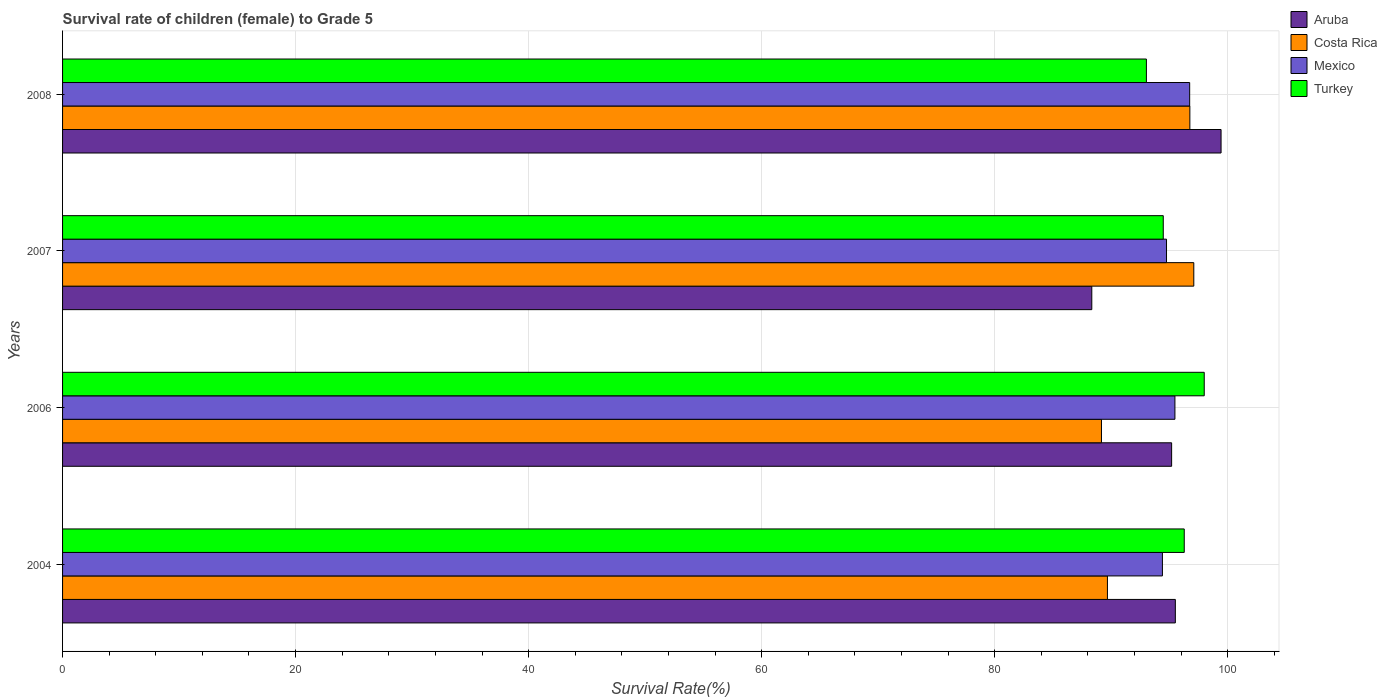How many different coloured bars are there?
Ensure brevity in your answer.  4. Are the number of bars per tick equal to the number of legend labels?
Provide a succinct answer. Yes. How many bars are there on the 4th tick from the top?
Make the answer very short. 4. How many bars are there on the 1st tick from the bottom?
Ensure brevity in your answer.  4. What is the label of the 4th group of bars from the top?
Make the answer very short. 2004. What is the survival rate of female children to grade 5 in Aruba in 2007?
Give a very brief answer. 88.34. Across all years, what is the maximum survival rate of female children to grade 5 in Costa Rica?
Make the answer very short. 97.09. Across all years, what is the minimum survival rate of female children to grade 5 in Costa Rica?
Offer a terse response. 89.17. What is the total survival rate of female children to grade 5 in Aruba in the graph?
Give a very brief answer. 378.48. What is the difference between the survival rate of female children to grade 5 in Turkey in 2007 and that in 2008?
Your answer should be very brief. 1.45. What is the difference between the survival rate of female children to grade 5 in Costa Rica in 2004 and the survival rate of female children to grade 5 in Mexico in 2007?
Keep it short and to the point. -5.07. What is the average survival rate of female children to grade 5 in Turkey per year?
Make the answer very short. 95.44. In the year 2008, what is the difference between the survival rate of female children to grade 5 in Costa Rica and survival rate of female children to grade 5 in Mexico?
Make the answer very short. 0.02. What is the ratio of the survival rate of female children to grade 5 in Turkey in 2006 to that in 2008?
Offer a very short reply. 1.05. Is the difference between the survival rate of female children to grade 5 in Costa Rica in 2004 and 2007 greater than the difference between the survival rate of female children to grade 5 in Mexico in 2004 and 2007?
Your answer should be very brief. No. What is the difference between the highest and the second highest survival rate of female children to grade 5 in Turkey?
Keep it short and to the point. 1.72. What is the difference between the highest and the lowest survival rate of female children to grade 5 in Aruba?
Give a very brief answer. 11.1. In how many years, is the survival rate of female children to grade 5 in Mexico greater than the average survival rate of female children to grade 5 in Mexico taken over all years?
Offer a terse response. 2. Is the sum of the survival rate of female children to grade 5 in Aruba in 2004 and 2008 greater than the maximum survival rate of female children to grade 5 in Turkey across all years?
Make the answer very short. Yes. What does the 1st bar from the top in 2007 represents?
Your answer should be compact. Turkey. What does the 4th bar from the bottom in 2004 represents?
Offer a very short reply. Turkey. Is it the case that in every year, the sum of the survival rate of female children to grade 5 in Aruba and survival rate of female children to grade 5 in Costa Rica is greater than the survival rate of female children to grade 5 in Turkey?
Offer a terse response. Yes. What is the difference between two consecutive major ticks on the X-axis?
Make the answer very short. 20. Are the values on the major ticks of X-axis written in scientific E-notation?
Ensure brevity in your answer.  No. Does the graph contain grids?
Make the answer very short. Yes. How are the legend labels stacked?
Your answer should be very brief. Vertical. What is the title of the graph?
Make the answer very short. Survival rate of children (female) to Grade 5. What is the label or title of the X-axis?
Ensure brevity in your answer.  Survival Rate(%). What is the label or title of the Y-axis?
Your response must be concise. Years. What is the Survival Rate(%) in Aruba in 2004?
Keep it short and to the point. 95.51. What is the Survival Rate(%) in Costa Rica in 2004?
Provide a succinct answer. 89.68. What is the Survival Rate(%) of Mexico in 2004?
Provide a succinct answer. 94.4. What is the Survival Rate(%) of Turkey in 2004?
Offer a terse response. 96.27. What is the Survival Rate(%) in Aruba in 2006?
Give a very brief answer. 95.19. What is the Survival Rate(%) in Costa Rica in 2006?
Your response must be concise. 89.17. What is the Survival Rate(%) of Mexico in 2006?
Provide a short and direct response. 95.47. What is the Survival Rate(%) in Turkey in 2006?
Offer a very short reply. 97.99. What is the Survival Rate(%) of Aruba in 2007?
Make the answer very short. 88.34. What is the Survival Rate(%) in Costa Rica in 2007?
Make the answer very short. 97.09. What is the Survival Rate(%) of Mexico in 2007?
Your response must be concise. 94.75. What is the Survival Rate(%) in Turkey in 2007?
Offer a terse response. 94.47. What is the Survival Rate(%) in Aruba in 2008?
Your response must be concise. 99.44. What is the Survival Rate(%) of Costa Rica in 2008?
Make the answer very short. 96.76. What is the Survival Rate(%) in Mexico in 2008?
Ensure brevity in your answer.  96.74. What is the Survival Rate(%) of Turkey in 2008?
Your answer should be very brief. 93.03. Across all years, what is the maximum Survival Rate(%) of Aruba?
Your answer should be very brief. 99.44. Across all years, what is the maximum Survival Rate(%) of Costa Rica?
Give a very brief answer. 97.09. Across all years, what is the maximum Survival Rate(%) in Mexico?
Make the answer very short. 96.74. Across all years, what is the maximum Survival Rate(%) of Turkey?
Your answer should be very brief. 97.99. Across all years, what is the minimum Survival Rate(%) in Aruba?
Give a very brief answer. 88.34. Across all years, what is the minimum Survival Rate(%) in Costa Rica?
Provide a succinct answer. 89.17. Across all years, what is the minimum Survival Rate(%) in Mexico?
Keep it short and to the point. 94.4. Across all years, what is the minimum Survival Rate(%) in Turkey?
Your answer should be compact. 93.03. What is the total Survival Rate(%) in Aruba in the graph?
Keep it short and to the point. 378.48. What is the total Survival Rate(%) of Costa Rica in the graph?
Your answer should be very brief. 372.7. What is the total Survival Rate(%) of Mexico in the graph?
Give a very brief answer. 381.37. What is the total Survival Rate(%) in Turkey in the graph?
Provide a succinct answer. 381.77. What is the difference between the Survival Rate(%) of Aruba in 2004 and that in 2006?
Your response must be concise. 0.32. What is the difference between the Survival Rate(%) in Costa Rica in 2004 and that in 2006?
Your response must be concise. 0.51. What is the difference between the Survival Rate(%) of Mexico in 2004 and that in 2006?
Provide a short and direct response. -1.07. What is the difference between the Survival Rate(%) in Turkey in 2004 and that in 2006?
Your answer should be compact. -1.72. What is the difference between the Survival Rate(%) of Aruba in 2004 and that in 2007?
Provide a short and direct response. 7.17. What is the difference between the Survival Rate(%) in Costa Rica in 2004 and that in 2007?
Ensure brevity in your answer.  -7.41. What is the difference between the Survival Rate(%) in Mexico in 2004 and that in 2007?
Your answer should be compact. -0.35. What is the difference between the Survival Rate(%) in Turkey in 2004 and that in 2007?
Offer a very short reply. 1.8. What is the difference between the Survival Rate(%) in Aruba in 2004 and that in 2008?
Offer a very short reply. -3.92. What is the difference between the Survival Rate(%) of Costa Rica in 2004 and that in 2008?
Offer a terse response. -7.08. What is the difference between the Survival Rate(%) of Mexico in 2004 and that in 2008?
Your answer should be very brief. -2.34. What is the difference between the Survival Rate(%) in Turkey in 2004 and that in 2008?
Give a very brief answer. 3.25. What is the difference between the Survival Rate(%) in Aruba in 2006 and that in 2007?
Keep it short and to the point. 6.85. What is the difference between the Survival Rate(%) in Costa Rica in 2006 and that in 2007?
Provide a short and direct response. -7.92. What is the difference between the Survival Rate(%) of Mexico in 2006 and that in 2007?
Keep it short and to the point. 0.72. What is the difference between the Survival Rate(%) of Turkey in 2006 and that in 2007?
Keep it short and to the point. 3.52. What is the difference between the Survival Rate(%) in Aruba in 2006 and that in 2008?
Ensure brevity in your answer.  -4.24. What is the difference between the Survival Rate(%) in Costa Rica in 2006 and that in 2008?
Offer a very short reply. -7.59. What is the difference between the Survival Rate(%) of Mexico in 2006 and that in 2008?
Your answer should be compact. -1.27. What is the difference between the Survival Rate(%) of Turkey in 2006 and that in 2008?
Provide a short and direct response. 4.96. What is the difference between the Survival Rate(%) of Aruba in 2007 and that in 2008?
Ensure brevity in your answer.  -11.1. What is the difference between the Survival Rate(%) of Costa Rica in 2007 and that in 2008?
Offer a very short reply. 0.34. What is the difference between the Survival Rate(%) of Mexico in 2007 and that in 2008?
Keep it short and to the point. -1.99. What is the difference between the Survival Rate(%) in Turkey in 2007 and that in 2008?
Provide a succinct answer. 1.45. What is the difference between the Survival Rate(%) of Aruba in 2004 and the Survival Rate(%) of Costa Rica in 2006?
Your response must be concise. 6.34. What is the difference between the Survival Rate(%) of Aruba in 2004 and the Survival Rate(%) of Mexico in 2006?
Provide a short and direct response. 0.04. What is the difference between the Survival Rate(%) of Aruba in 2004 and the Survival Rate(%) of Turkey in 2006?
Provide a short and direct response. -2.48. What is the difference between the Survival Rate(%) in Costa Rica in 2004 and the Survival Rate(%) in Mexico in 2006?
Your response must be concise. -5.79. What is the difference between the Survival Rate(%) in Costa Rica in 2004 and the Survival Rate(%) in Turkey in 2006?
Your answer should be compact. -8.31. What is the difference between the Survival Rate(%) of Mexico in 2004 and the Survival Rate(%) of Turkey in 2006?
Your answer should be compact. -3.59. What is the difference between the Survival Rate(%) in Aruba in 2004 and the Survival Rate(%) in Costa Rica in 2007?
Provide a short and direct response. -1.58. What is the difference between the Survival Rate(%) of Aruba in 2004 and the Survival Rate(%) of Mexico in 2007?
Provide a succinct answer. 0.76. What is the difference between the Survival Rate(%) of Aruba in 2004 and the Survival Rate(%) of Turkey in 2007?
Offer a terse response. 1.04. What is the difference between the Survival Rate(%) in Costa Rica in 2004 and the Survival Rate(%) in Mexico in 2007?
Make the answer very short. -5.07. What is the difference between the Survival Rate(%) of Costa Rica in 2004 and the Survival Rate(%) of Turkey in 2007?
Make the answer very short. -4.79. What is the difference between the Survival Rate(%) of Mexico in 2004 and the Survival Rate(%) of Turkey in 2007?
Keep it short and to the point. -0.07. What is the difference between the Survival Rate(%) in Aruba in 2004 and the Survival Rate(%) in Costa Rica in 2008?
Ensure brevity in your answer.  -1.25. What is the difference between the Survival Rate(%) in Aruba in 2004 and the Survival Rate(%) in Mexico in 2008?
Your answer should be compact. -1.23. What is the difference between the Survival Rate(%) of Aruba in 2004 and the Survival Rate(%) of Turkey in 2008?
Offer a terse response. 2.48. What is the difference between the Survival Rate(%) in Costa Rica in 2004 and the Survival Rate(%) in Mexico in 2008?
Your answer should be compact. -7.06. What is the difference between the Survival Rate(%) in Costa Rica in 2004 and the Survival Rate(%) in Turkey in 2008?
Your answer should be very brief. -3.35. What is the difference between the Survival Rate(%) in Mexico in 2004 and the Survival Rate(%) in Turkey in 2008?
Offer a very short reply. 1.37. What is the difference between the Survival Rate(%) of Aruba in 2006 and the Survival Rate(%) of Costa Rica in 2007?
Your response must be concise. -1.9. What is the difference between the Survival Rate(%) in Aruba in 2006 and the Survival Rate(%) in Mexico in 2007?
Your answer should be very brief. 0.44. What is the difference between the Survival Rate(%) in Aruba in 2006 and the Survival Rate(%) in Turkey in 2007?
Your response must be concise. 0.72. What is the difference between the Survival Rate(%) of Costa Rica in 2006 and the Survival Rate(%) of Mexico in 2007?
Provide a succinct answer. -5.58. What is the difference between the Survival Rate(%) of Costa Rica in 2006 and the Survival Rate(%) of Turkey in 2007?
Your answer should be very brief. -5.3. What is the difference between the Survival Rate(%) in Aruba in 2006 and the Survival Rate(%) in Costa Rica in 2008?
Provide a succinct answer. -1.57. What is the difference between the Survival Rate(%) of Aruba in 2006 and the Survival Rate(%) of Mexico in 2008?
Your response must be concise. -1.55. What is the difference between the Survival Rate(%) in Aruba in 2006 and the Survival Rate(%) in Turkey in 2008?
Make the answer very short. 2.16. What is the difference between the Survival Rate(%) of Costa Rica in 2006 and the Survival Rate(%) of Mexico in 2008?
Your answer should be very brief. -7.57. What is the difference between the Survival Rate(%) of Costa Rica in 2006 and the Survival Rate(%) of Turkey in 2008?
Provide a short and direct response. -3.86. What is the difference between the Survival Rate(%) of Mexico in 2006 and the Survival Rate(%) of Turkey in 2008?
Ensure brevity in your answer.  2.45. What is the difference between the Survival Rate(%) of Aruba in 2007 and the Survival Rate(%) of Costa Rica in 2008?
Your answer should be very brief. -8.42. What is the difference between the Survival Rate(%) of Aruba in 2007 and the Survival Rate(%) of Mexico in 2008?
Ensure brevity in your answer.  -8.4. What is the difference between the Survival Rate(%) in Aruba in 2007 and the Survival Rate(%) in Turkey in 2008?
Keep it short and to the point. -4.69. What is the difference between the Survival Rate(%) of Costa Rica in 2007 and the Survival Rate(%) of Mexico in 2008?
Your response must be concise. 0.35. What is the difference between the Survival Rate(%) of Costa Rica in 2007 and the Survival Rate(%) of Turkey in 2008?
Ensure brevity in your answer.  4.07. What is the difference between the Survival Rate(%) in Mexico in 2007 and the Survival Rate(%) in Turkey in 2008?
Offer a terse response. 1.73. What is the average Survival Rate(%) in Aruba per year?
Give a very brief answer. 94.62. What is the average Survival Rate(%) of Costa Rica per year?
Provide a succinct answer. 93.18. What is the average Survival Rate(%) in Mexico per year?
Your answer should be very brief. 95.34. What is the average Survival Rate(%) in Turkey per year?
Give a very brief answer. 95.44. In the year 2004, what is the difference between the Survival Rate(%) of Aruba and Survival Rate(%) of Costa Rica?
Keep it short and to the point. 5.83. In the year 2004, what is the difference between the Survival Rate(%) of Aruba and Survival Rate(%) of Mexico?
Keep it short and to the point. 1.11. In the year 2004, what is the difference between the Survival Rate(%) of Aruba and Survival Rate(%) of Turkey?
Give a very brief answer. -0.76. In the year 2004, what is the difference between the Survival Rate(%) in Costa Rica and Survival Rate(%) in Mexico?
Provide a short and direct response. -4.72. In the year 2004, what is the difference between the Survival Rate(%) of Costa Rica and Survival Rate(%) of Turkey?
Ensure brevity in your answer.  -6.59. In the year 2004, what is the difference between the Survival Rate(%) of Mexico and Survival Rate(%) of Turkey?
Your answer should be very brief. -1.87. In the year 2006, what is the difference between the Survival Rate(%) of Aruba and Survival Rate(%) of Costa Rica?
Your answer should be compact. 6.02. In the year 2006, what is the difference between the Survival Rate(%) of Aruba and Survival Rate(%) of Mexico?
Your response must be concise. -0.28. In the year 2006, what is the difference between the Survival Rate(%) in Aruba and Survival Rate(%) in Turkey?
Give a very brief answer. -2.8. In the year 2006, what is the difference between the Survival Rate(%) in Costa Rica and Survival Rate(%) in Mexico?
Offer a terse response. -6.3. In the year 2006, what is the difference between the Survival Rate(%) of Costa Rica and Survival Rate(%) of Turkey?
Your response must be concise. -8.82. In the year 2006, what is the difference between the Survival Rate(%) of Mexico and Survival Rate(%) of Turkey?
Make the answer very short. -2.52. In the year 2007, what is the difference between the Survival Rate(%) of Aruba and Survival Rate(%) of Costa Rica?
Give a very brief answer. -8.75. In the year 2007, what is the difference between the Survival Rate(%) in Aruba and Survival Rate(%) in Mexico?
Provide a short and direct response. -6.41. In the year 2007, what is the difference between the Survival Rate(%) of Aruba and Survival Rate(%) of Turkey?
Provide a succinct answer. -6.13. In the year 2007, what is the difference between the Survival Rate(%) in Costa Rica and Survival Rate(%) in Mexico?
Your response must be concise. 2.34. In the year 2007, what is the difference between the Survival Rate(%) in Costa Rica and Survival Rate(%) in Turkey?
Keep it short and to the point. 2.62. In the year 2007, what is the difference between the Survival Rate(%) of Mexico and Survival Rate(%) of Turkey?
Provide a succinct answer. 0.28. In the year 2008, what is the difference between the Survival Rate(%) in Aruba and Survival Rate(%) in Costa Rica?
Offer a terse response. 2.68. In the year 2008, what is the difference between the Survival Rate(%) of Aruba and Survival Rate(%) of Mexico?
Offer a very short reply. 2.69. In the year 2008, what is the difference between the Survival Rate(%) of Aruba and Survival Rate(%) of Turkey?
Make the answer very short. 6.41. In the year 2008, what is the difference between the Survival Rate(%) in Costa Rica and Survival Rate(%) in Mexico?
Provide a short and direct response. 0.02. In the year 2008, what is the difference between the Survival Rate(%) of Costa Rica and Survival Rate(%) of Turkey?
Keep it short and to the point. 3.73. In the year 2008, what is the difference between the Survival Rate(%) in Mexico and Survival Rate(%) in Turkey?
Make the answer very short. 3.71. What is the ratio of the Survival Rate(%) of Aruba in 2004 to that in 2006?
Ensure brevity in your answer.  1. What is the ratio of the Survival Rate(%) in Mexico in 2004 to that in 2006?
Your response must be concise. 0.99. What is the ratio of the Survival Rate(%) of Turkey in 2004 to that in 2006?
Keep it short and to the point. 0.98. What is the ratio of the Survival Rate(%) of Aruba in 2004 to that in 2007?
Ensure brevity in your answer.  1.08. What is the ratio of the Survival Rate(%) of Costa Rica in 2004 to that in 2007?
Provide a succinct answer. 0.92. What is the ratio of the Survival Rate(%) in Turkey in 2004 to that in 2007?
Your answer should be compact. 1.02. What is the ratio of the Survival Rate(%) in Aruba in 2004 to that in 2008?
Offer a very short reply. 0.96. What is the ratio of the Survival Rate(%) in Costa Rica in 2004 to that in 2008?
Keep it short and to the point. 0.93. What is the ratio of the Survival Rate(%) of Mexico in 2004 to that in 2008?
Ensure brevity in your answer.  0.98. What is the ratio of the Survival Rate(%) in Turkey in 2004 to that in 2008?
Make the answer very short. 1.03. What is the ratio of the Survival Rate(%) of Aruba in 2006 to that in 2007?
Provide a succinct answer. 1.08. What is the ratio of the Survival Rate(%) of Costa Rica in 2006 to that in 2007?
Provide a succinct answer. 0.92. What is the ratio of the Survival Rate(%) of Mexico in 2006 to that in 2007?
Make the answer very short. 1.01. What is the ratio of the Survival Rate(%) in Turkey in 2006 to that in 2007?
Ensure brevity in your answer.  1.04. What is the ratio of the Survival Rate(%) in Aruba in 2006 to that in 2008?
Give a very brief answer. 0.96. What is the ratio of the Survival Rate(%) in Costa Rica in 2006 to that in 2008?
Your answer should be compact. 0.92. What is the ratio of the Survival Rate(%) of Mexico in 2006 to that in 2008?
Keep it short and to the point. 0.99. What is the ratio of the Survival Rate(%) in Turkey in 2006 to that in 2008?
Keep it short and to the point. 1.05. What is the ratio of the Survival Rate(%) in Aruba in 2007 to that in 2008?
Offer a very short reply. 0.89. What is the ratio of the Survival Rate(%) in Mexico in 2007 to that in 2008?
Offer a terse response. 0.98. What is the ratio of the Survival Rate(%) of Turkey in 2007 to that in 2008?
Provide a short and direct response. 1.02. What is the difference between the highest and the second highest Survival Rate(%) in Aruba?
Offer a very short reply. 3.92. What is the difference between the highest and the second highest Survival Rate(%) in Costa Rica?
Offer a very short reply. 0.34. What is the difference between the highest and the second highest Survival Rate(%) of Mexico?
Make the answer very short. 1.27. What is the difference between the highest and the second highest Survival Rate(%) in Turkey?
Offer a very short reply. 1.72. What is the difference between the highest and the lowest Survival Rate(%) in Aruba?
Ensure brevity in your answer.  11.1. What is the difference between the highest and the lowest Survival Rate(%) in Costa Rica?
Offer a very short reply. 7.92. What is the difference between the highest and the lowest Survival Rate(%) of Mexico?
Offer a very short reply. 2.34. What is the difference between the highest and the lowest Survival Rate(%) of Turkey?
Provide a short and direct response. 4.96. 